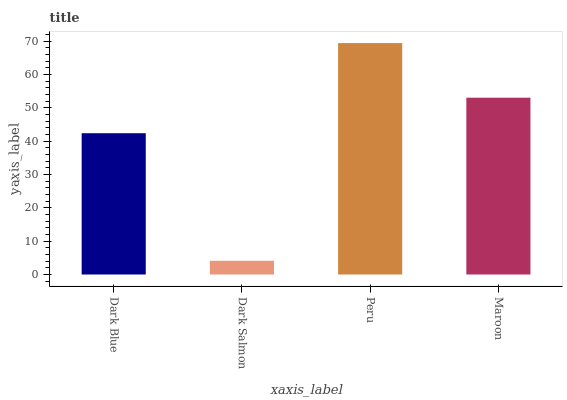Is Dark Salmon the minimum?
Answer yes or no. Yes. Is Peru the maximum?
Answer yes or no. Yes. Is Peru the minimum?
Answer yes or no. No. Is Dark Salmon the maximum?
Answer yes or no. No. Is Peru greater than Dark Salmon?
Answer yes or no. Yes. Is Dark Salmon less than Peru?
Answer yes or no. Yes. Is Dark Salmon greater than Peru?
Answer yes or no. No. Is Peru less than Dark Salmon?
Answer yes or no. No. Is Maroon the high median?
Answer yes or no. Yes. Is Dark Blue the low median?
Answer yes or no. Yes. Is Dark Blue the high median?
Answer yes or no. No. Is Maroon the low median?
Answer yes or no. No. 